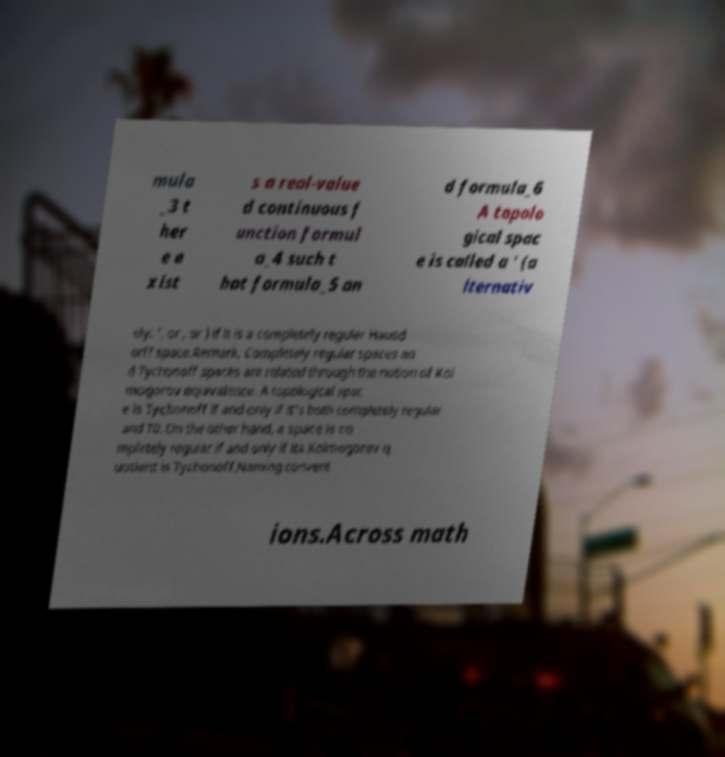Please read and relay the text visible in this image. What does it say? mula _3 t her e e xist s a real-value d continuous f unction formul a_4 such t hat formula_5 an d formula_6 A topolo gical spac e is called a ' (a lternativ ely: ', or , or ) if it is a completely regular Hausd orff space.Remark. Completely regular spaces an d Tychonoff spaces are related through the notion of Kol mogorov equivalence. A topological spac e is Tychonoff if and only if it's both completely regular and T0. On the other hand, a space is co mpletely regular if and only if its Kolmogorov q uotient is Tychonoff.Naming convent ions.Across math 